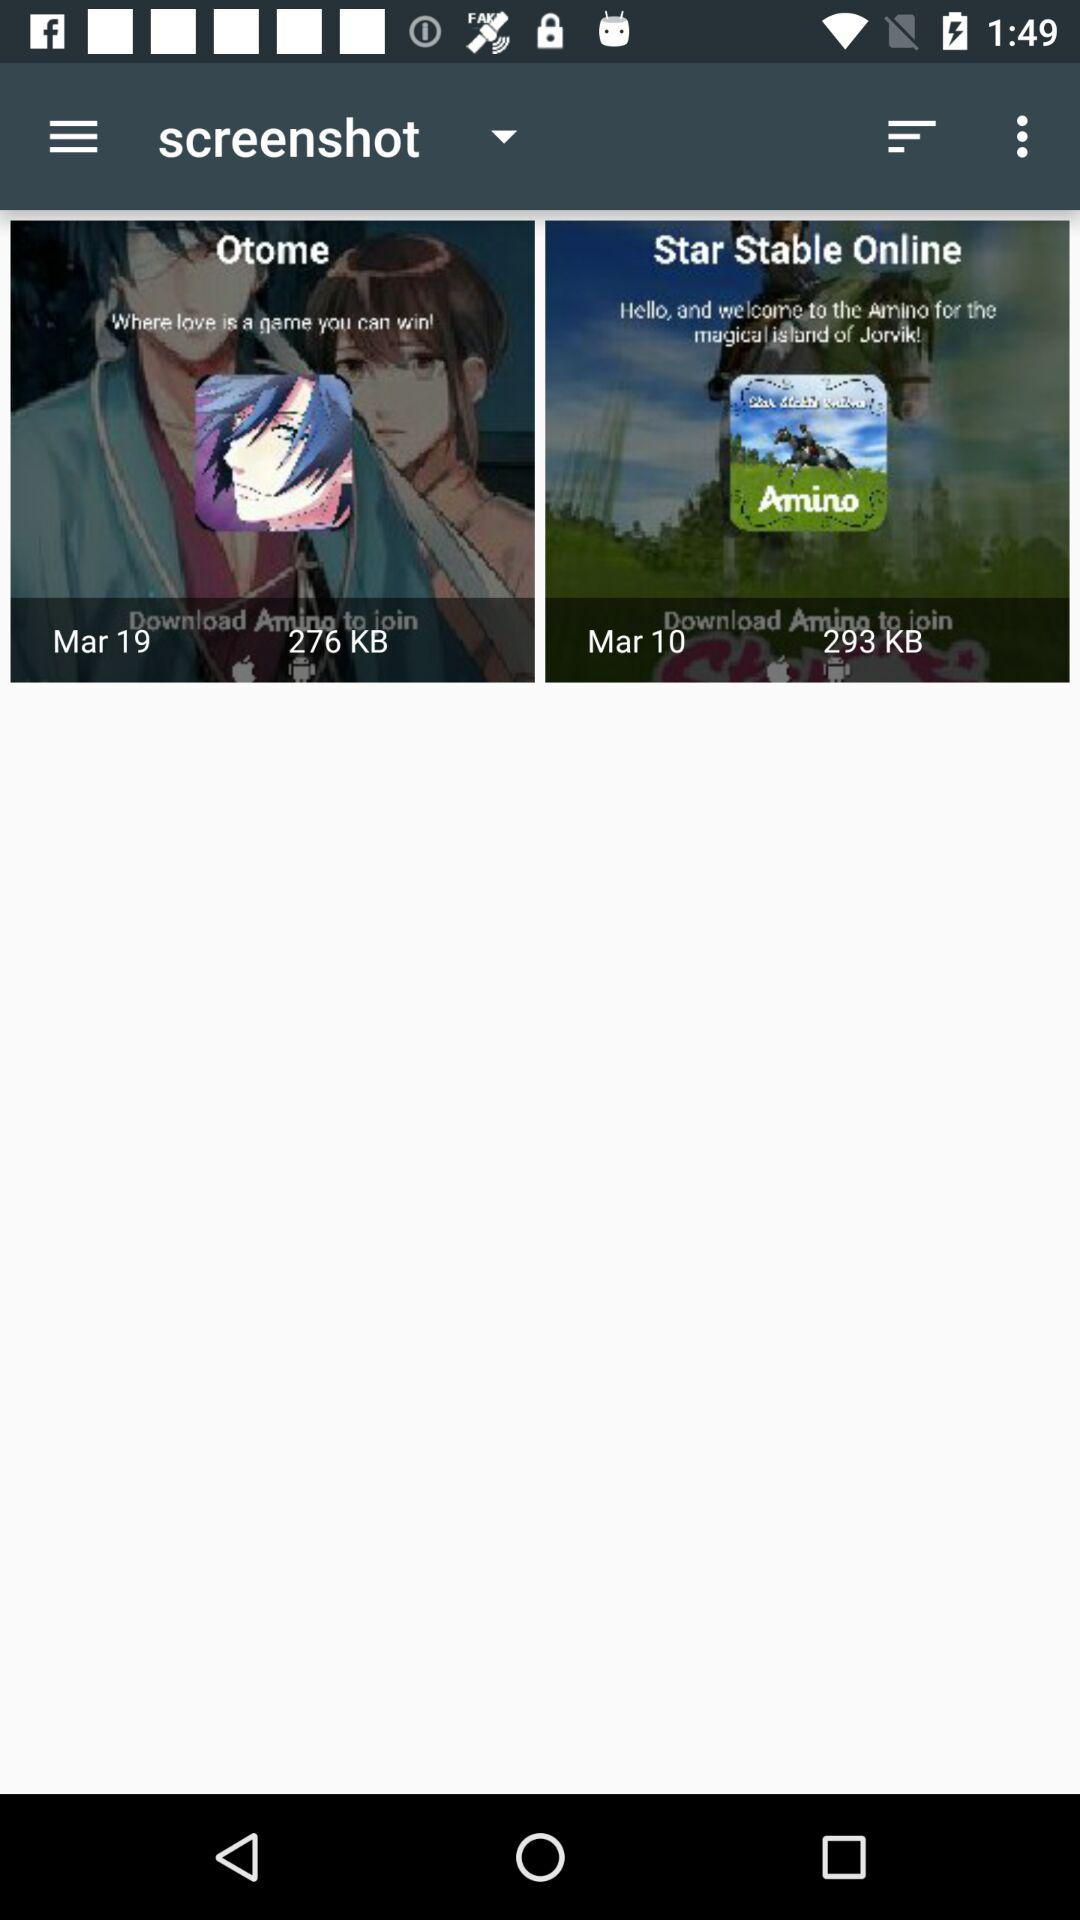What is the speed?
When the provided information is insufficient, respond with <no answer>. <no answer> 